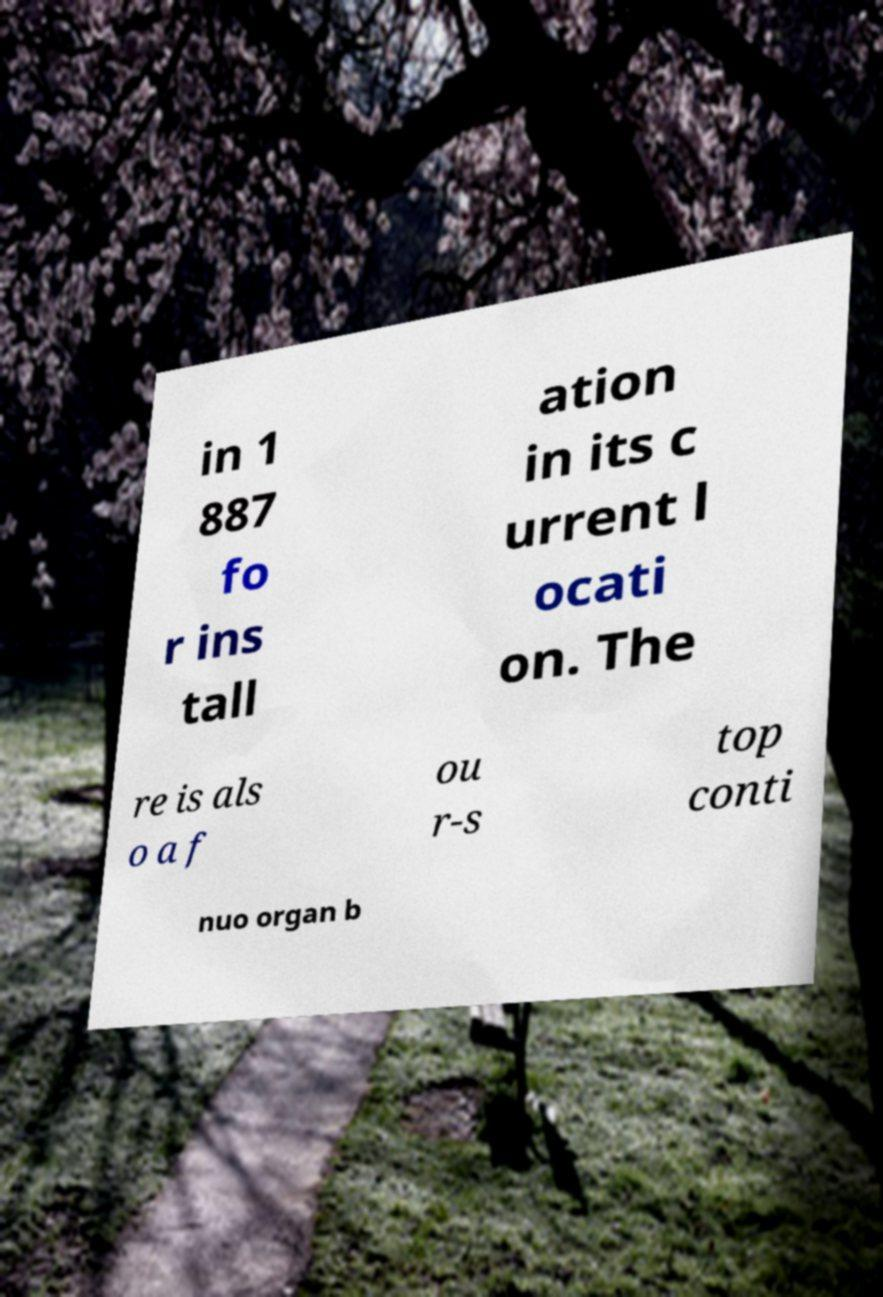Please identify and transcribe the text found in this image. in 1 887 fo r ins tall ation in its c urrent l ocati on. The re is als o a f ou r-s top conti nuo organ b 